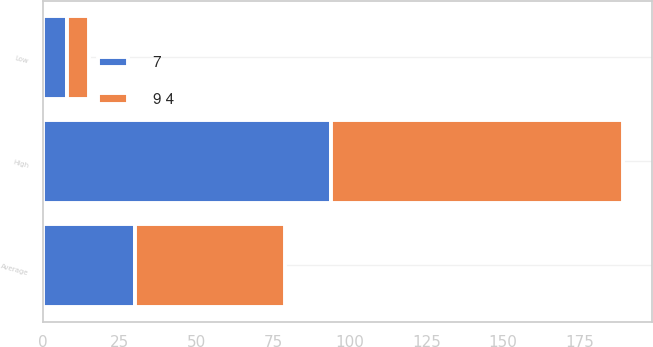Convert chart to OTSL. <chart><loc_0><loc_0><loc_500><loc_500><stacked_bar_chart><ecel><fcel>Average<fcel>High<fcel>Low<nl><fcel>9 4<fcel>49<fcel>95<fcel>7<nl><fcel>7<fcel>30<fcel>94<fcel>8<nl></chart> 